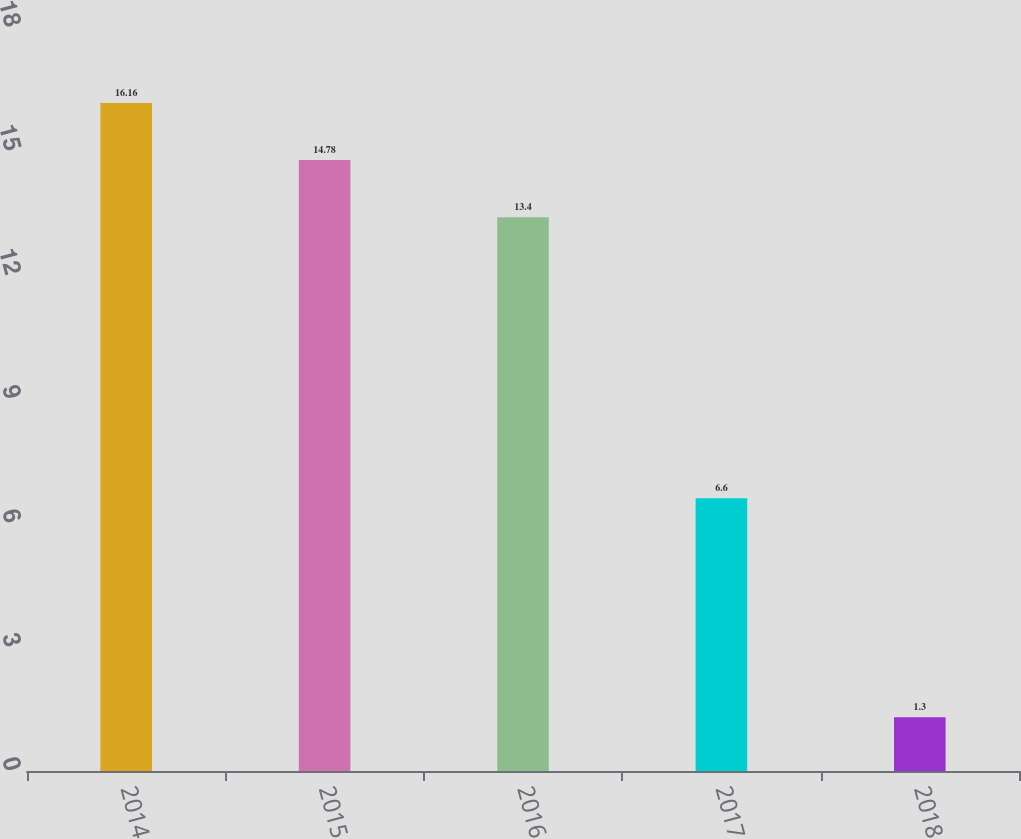Convert chart to OTSL. <chart><loc_0><loc_0><loc_500><loc_500><bar_chart><fcel>2014<fcel>2015<fcel>2016<fcel>2017<fcel>2018<nl><fcel>16.16<fcel>14.78<fcel>13.4<fcel>6.6<fcel>1.3<nl></chart> 